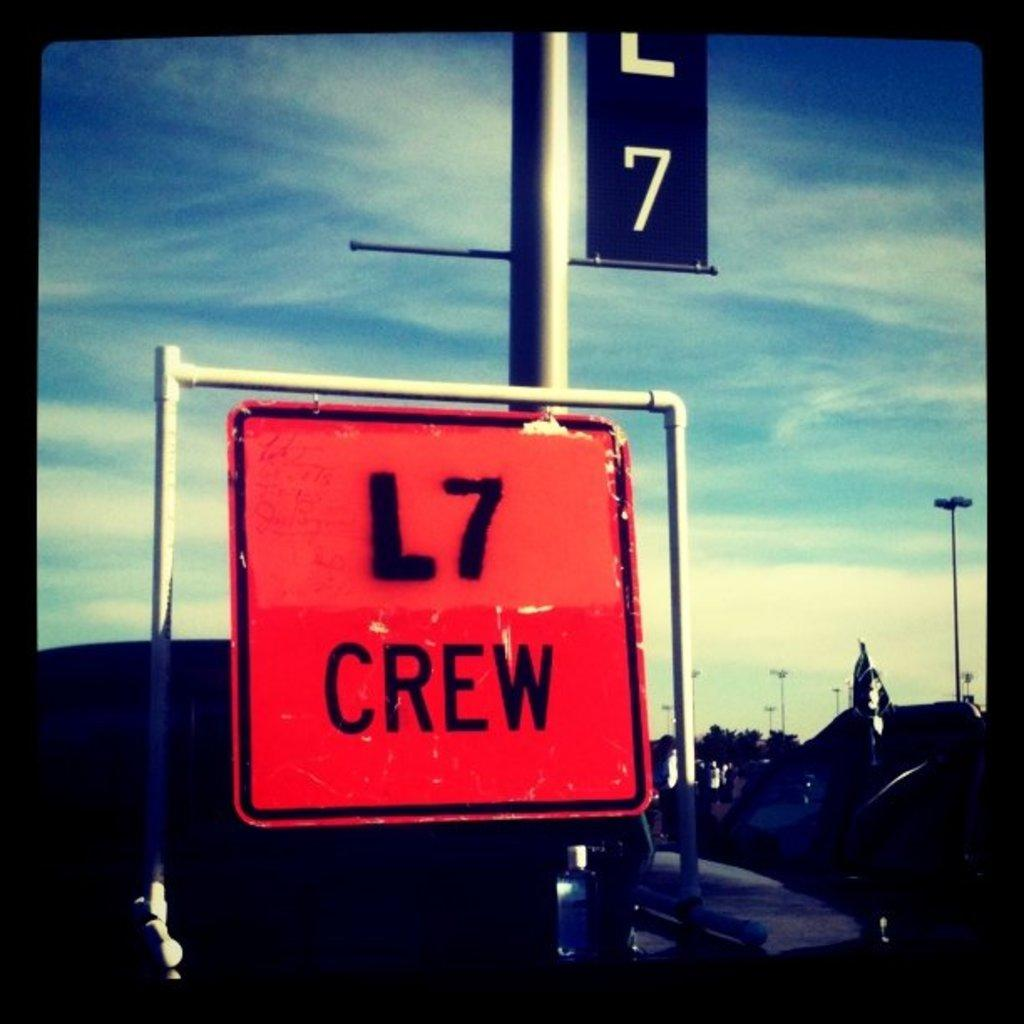Provide a one-sentence caption for the provided image. A bright orange sign for the L7 Crew sits under a blue sky. 